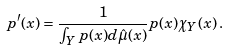<formula> <loc_0><loc_0><loc_500><loc_500>p ^ { \prime } ( x ) = \frac { 1 } { \int _ { Y } p ( x ) d \hat { \mu } ( x ) } p ( x ) \chi _ { Y } ( x ) \, .</formula> 